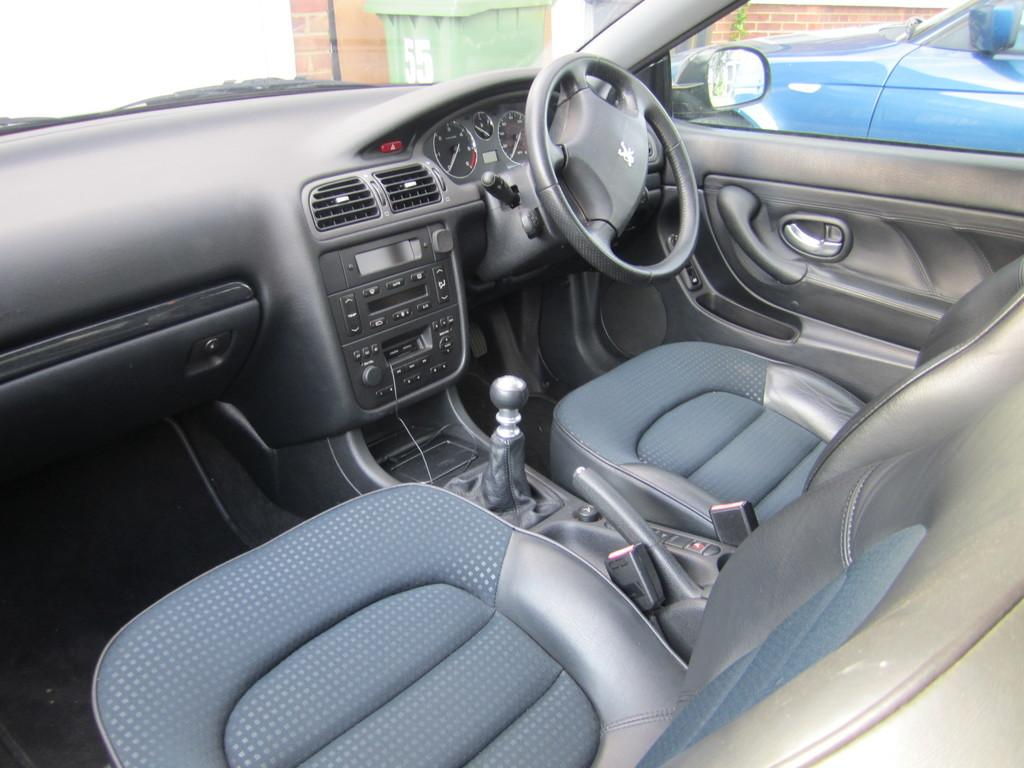What type of setting is depicted in the image? The image represents the interiors of a car. Can you describe anything visible outside the car in the image? There is another car visible outside the car in the image. What type of meat is being cooked in the image? There is no meat or cooking activity present in the image; it depicts the interiors of a car. 